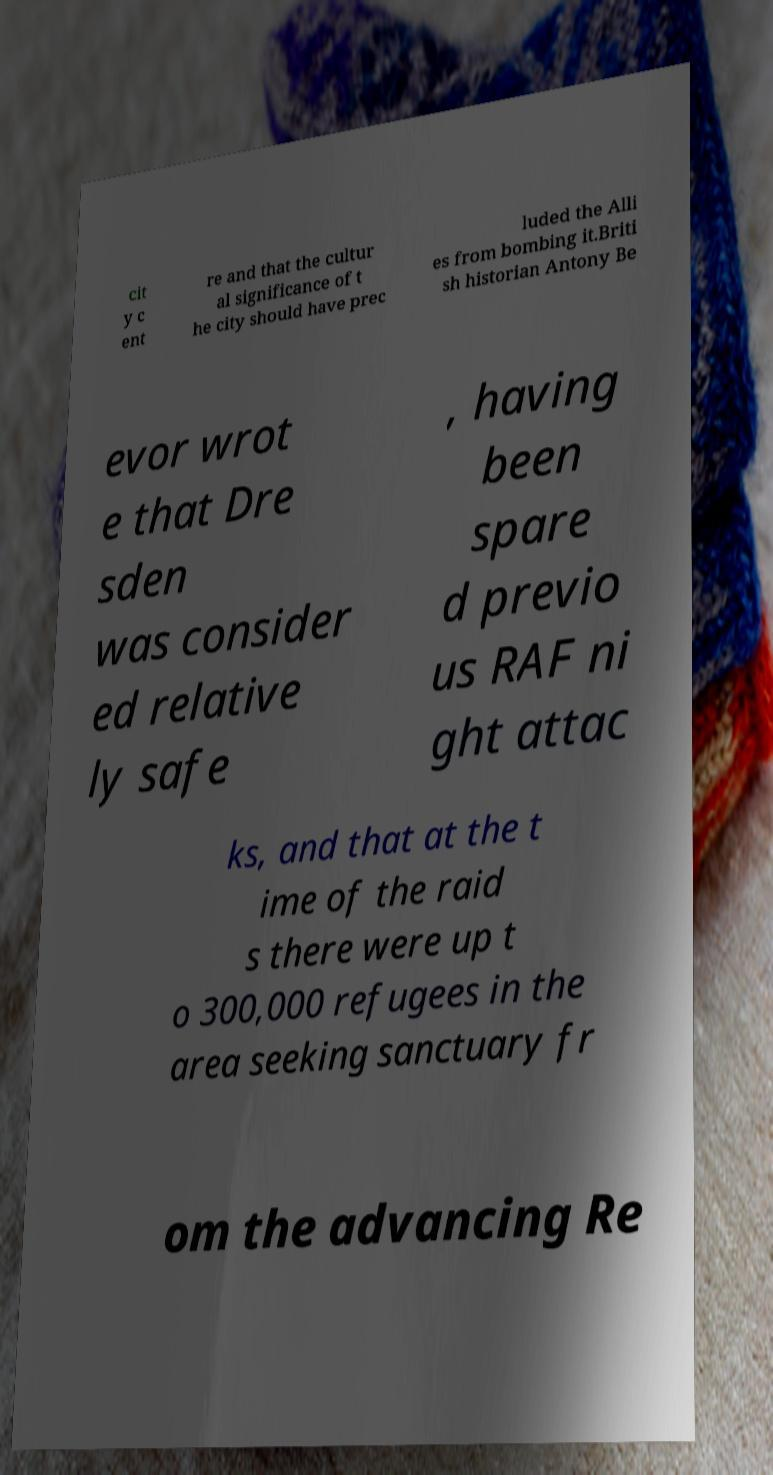Could you assist in decoding the text presented in this image and type it out clearly? cit y c ent re and that the cultur al significance of t he city should have prec luded the Alli es from bombing it.Briti sh historian Antony Be evor wrot e that Dre sden was consider ed relative ly safe , having been spare d previo us RAF ni ght attac ks, and that at the t ime of the raid s there were up t o 300,000 refugees in the area seeking sanctuary fr om the advancing Re 